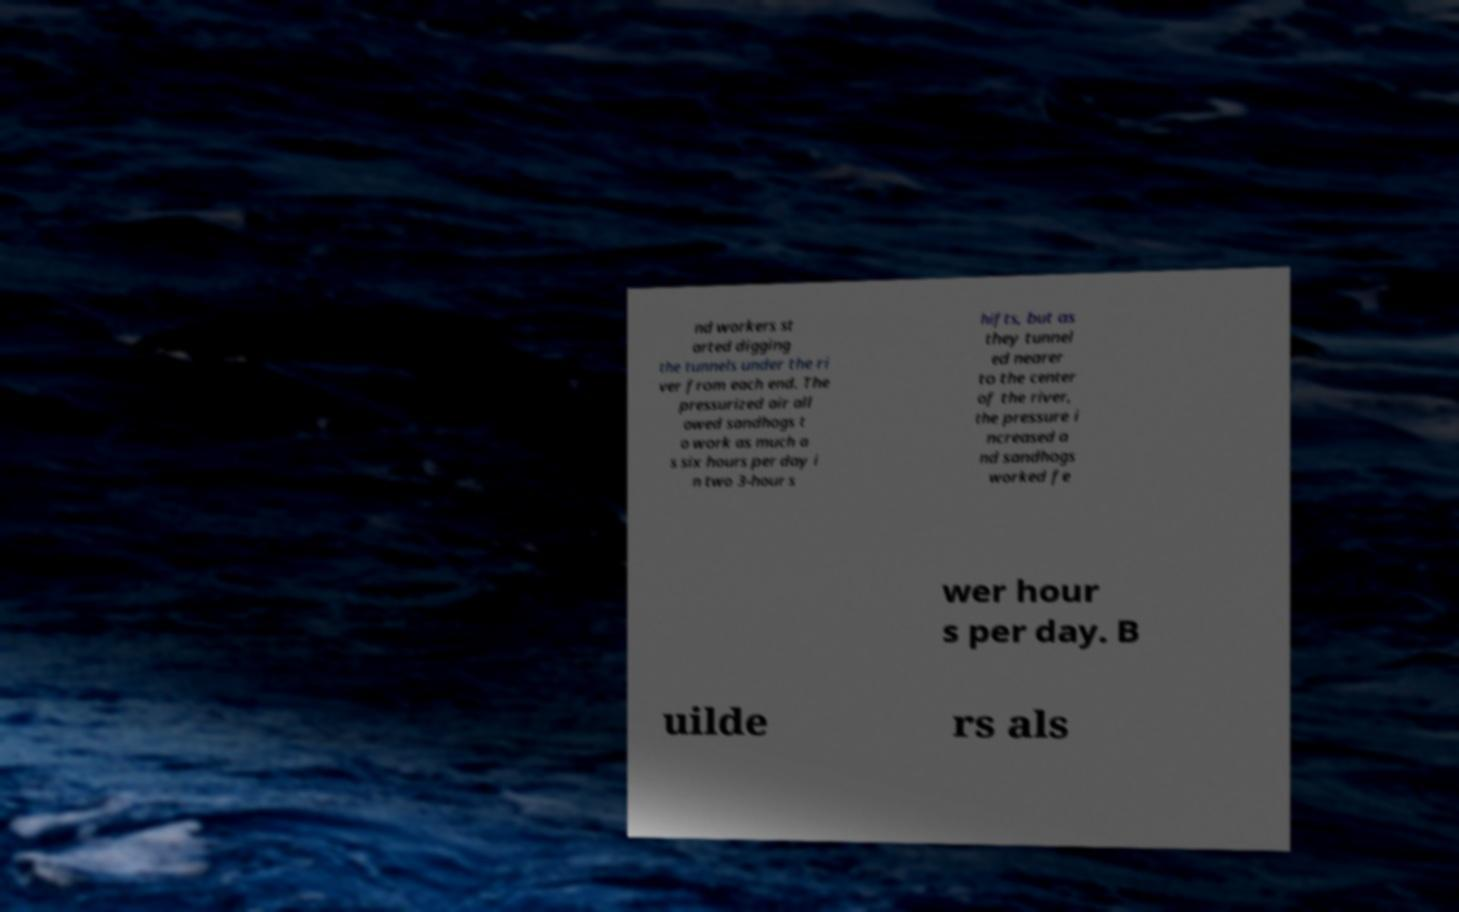For documentation purposes, I need the text within this image transcribed. Could you provide that? nd workers st arted digging the tunnels under the ri ver from each end. The pressurized air all owed sandhogs t o work as much a s six hours per day i n two 3-hour s hifts, but as they tunnel ed nearer to the center of the river, the pressure i ncreased a nd sandhogs worked fe wer hour s per day. B uilde rs als 